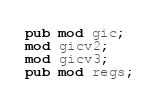<code> <loc_0><loc_0><loc_500><loc_500><_Rust_>pub mod gic;
mod gicv2;
mod gicv3;
pub mod regs;
</code> 